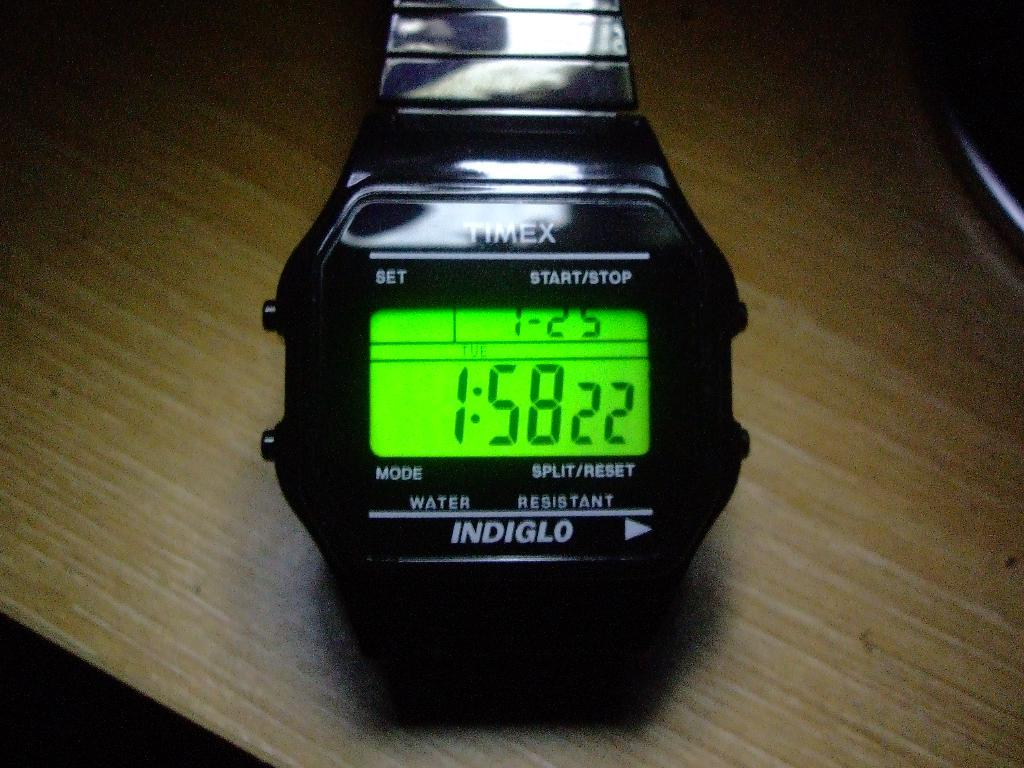<image>
Offer a succinct explanation of the picture presented. An indiglo watch made by Timex shows the date and time. 